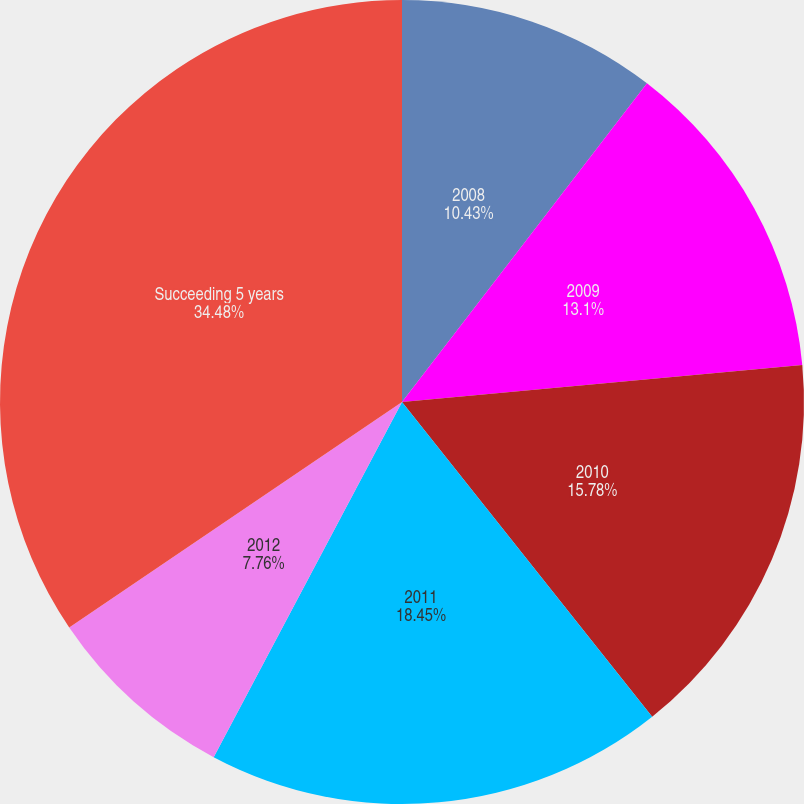Convert chart to OTSL. <chart><loc_0><loc_0><loc_500><loc_500><pie_chart><fcel>2008<fcel>2009<fcel>2010<fcel>2011<fcel>2012<fcel>Succeeding 5 years<nl><fcel>10.43%<fcel>13.1%<fcel>15.78%<fcel>18.45%<fcel>7.76%<fcel>34.48%<nl></chart> 